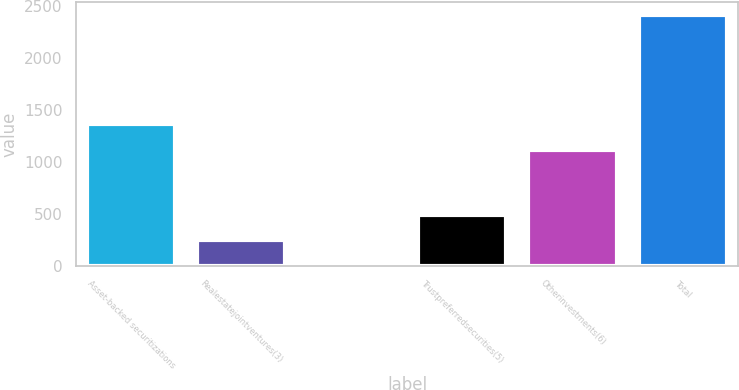<chart> <loc_0><loc_0><loc_500><loc_500><bar_chart><fcel>Asset-backed securitizations<fcel>Realestatejointventures(3)<fcel>Unnamed: 2<fcel>Trustpreferredsecurities(5)<fcel>Otherinvestments(6)<fcel>Total<nl><fcel>1360.7<fcel>242.7<fcel>1<fcel>484.4<fcel>1119<fcel>2418<nl></chart> 